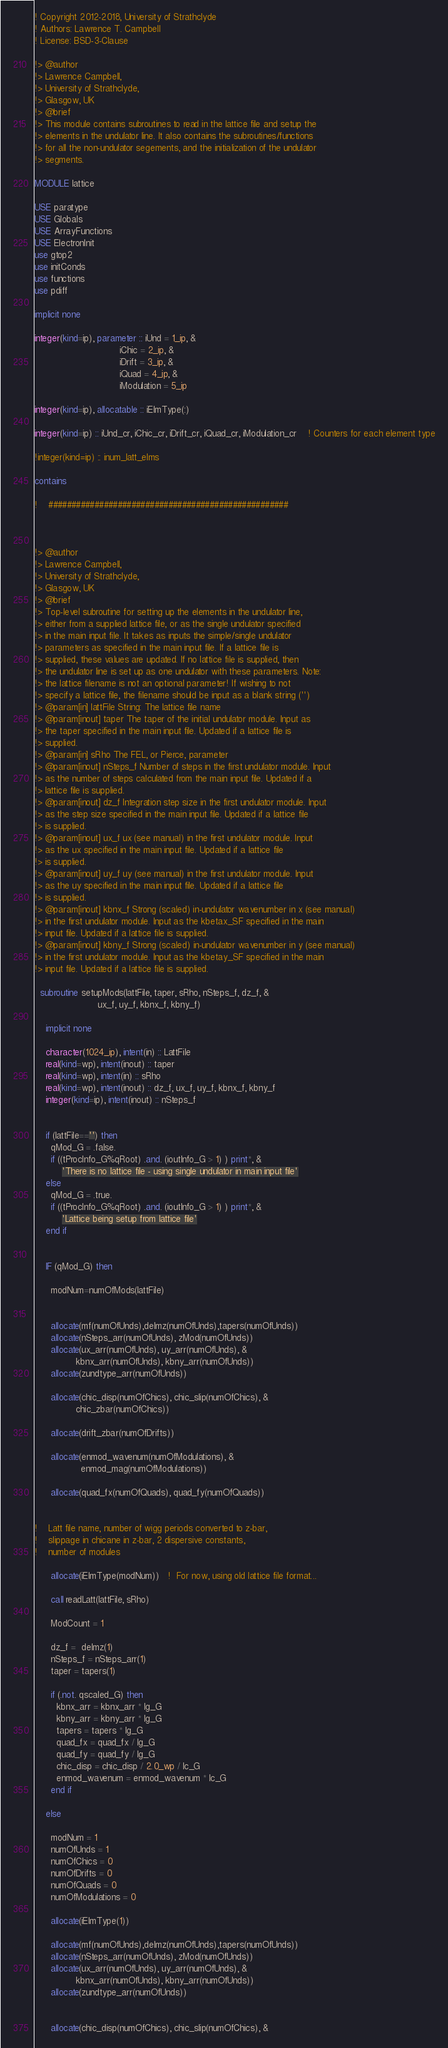<code> <loc_0><loc_0><loc_500><loc_500><_FORTRAN_>! Copyright 2012-2018, University of Strathclyde
! Authors: Lawrence T. Campbell
! License: BSD-3-Clause

!> @author
!> Lawrence Campbell,
!> University of Strathclyde, 
!> Glasgow, UK
!> @brief
!> This module contains subroutines to read in the lattice file and setup the
!> elements in the undulator line. It also contains the subroutines/functions 
!> for all the non-undulator segements, and the initialization of the undulator
!> segments.

MODULE lattice

USE paratype
USE Globals
USE ArrayFunctions
USE ElectronInit
use gtop2
use initConds
use functions
use pdiff

implicit none

integer(kind=ip), parameter :: iUnd = 1_ip, &
                               iChic = 2_ip, &
                               iDrift = 3_ip, &
                               iQuad = 4_ip, &
                               iModulation = 5_ip

integer(kind=ip), allocatable :: iElmType(:)

integer(kind=ip) :: iUnd_cr, iChic_cr, iDrift_cr, iQuad_cr, iModulation_cr    ! Counters for each element type

!integer(kind=ip) :: inum_latt_elms

contains

!    ####################################################



!> @author
!> Lawrence Campbell,
!> University of Strathclyde, 
!> Glasgow, UK
!> @brief
!> Top-level subroutine for setting up the elements in the undulator line, 
!> either from a supplied lattice file, or as the single undulator specified
!> in the main input file. It takes as inputs the simple/single undulator 
!> parameters as specified in the main input file. If a lattice file is 
!> supplied, these values are updated. If no lattice file is supplied, then
!> the undulator line is set up as one undulator with these parameters. Note:
!> the lattice filename is not an optional parameter! If wishing to not 
!> specify a lattice file, the filename should be input as a blank string ('')
!> @param[in] lattFile String: The lattice file name
!> @param[inout] taper The taper of the initial undulator module. Input as 
!> the taper specified in the main input file. Updated if a lattice file is 
!> supplied.
!> @param[in] sRho The FEL, or Pierce, parameter
!> @param[inout] nSteps_f Number of steps in the first undulator module. Input
!> as the number of steps calculated from the main input file. Updated if a  
!> lattice file is supplied.
!> @param[inout] dz_f Integration step size in the first undulator module. Input
!> as the step size specified in the main input file. Updated if a lattice file 
!> is supplied.
!> @param[inout] ux_f ux (see manual) in the first undulator module. Input
!> as the ux specified in the main input file. Updated if a lattice file 
!> is supplied.
!> @param[inout] uy_f uy (see manual) in the first undulator module. Input
!> as the uy specified in the main input file. Updated if a lattice file 
!> is supplied.
!> @param[inout] kbnx_f Strong (scaled) in-undulator wavenumber in x (see manual) 
!> in the first undulator module. Input as the kbetax_SF specified in the main 
!> input file. Updated if a lattice file is supplied.
!> @param[inout] kbny_f Strong (scaled) in-undulator wavenumber in y (see manual) 
!> in the first undulator module. Input as the kbetay_SF specified in the main 
!> input file. Updated if a lattice file is supplied.

  subroutine setupMods(lattFile, taper, sRho, nSteps_f, dz_f, &
                       ux_f, uy_f, kbnx_f, kbny_f)

    implicit none

    character(1024_ip), intent(in) :: LattFile 
    real(kind=wp), intent(inout) :: taper
    real(kind=wp), intent(in) :: sRho
    real(kind=wp), intent(inout) :: dz_f, ux_f, uy_f, kbnx_f, kbny_f
    integer(kind=ip), intent(inout) :: nSteps_f


    if (lattFile=='') then
      qMod_G = .false.
      if ((tProcInfo_G%qRoot) .and. (ioutInfo_G > 1) ) print*, &
          'There is no lattice file - using single undulator in main input file'
    else
      qMod_G = .true.
      if ((tProcInfo_G%qRoot) .and. (ioutInfo_G > 1) ) print*, &
          'Lattice being setup from lattice file'
    end if


    IF (qMod_G) then

      modNum=numOfMods(lattFile)


      allocate(mf(numOfUnds),delmz(numOfUnds),tapers(numOfUnds))
      allocate(nSteps_arr(numOfUnds), zMod(numOfUnds))
      allocate(ux_arr(numOfUnds), uy_arr(numOfUnds), &
               kbnx_arr(numOfUnds), kbny_arr(numOfUnds))
      allocate(zundtype_arr(numOfUnds))

      allocate(chic_disp(numOfChics), chic_slip(numOfChics), &
               chic_zbar(numOfChics))

      allocate(drift_zbar(numOfDrifts))

      allocate(enmod_wavenum(numOfModulations), &
                 enmod_mag(numOfModulations)) 

      allocate(quad_fx(numOfQuads), quad_fy(numOfQuads))


!    Latt file name, number of wigg periods converted to z-bar,
!    slippage in chicane in z-bar, 2 dispersive constants,
!    number of modules

      allocate(iElmType(modNum))   !  For now, using old lattice file format...

      call readLatt(lattFile, sRho)

      ModCount = 1

      dz_f =  delmz(1)
      nSteps_f = nSteps_arr(1)
      taper = tapers(1)

      if (.not. qscaled_G) then
        kbnx_arr = kbnx_arr * lg_G
        kbny_arr = kbny_arr * lg_G
        tapers = tapers * lg_G
        quad_fx = quad_fx / lg_G
        quad_fy = quad_fy / lg_G
        chic_disp = chic_disp / 2.0_wp / lc_G
        enmod_wavenum = enmod_wavenum * lc_G
      end if

    else

      modNum = 1
      numOfUnds = 1
      numOfChics = 0
      numOfDrifts = 0
      numOfQuads = 0
      numOfModulations = 0

      allocate(iElmType(1))

      allocate(mf(numOfUnds),delmz(numOfUnds),tapers(numOfUnds))
      allocate(nSteps_arr(numOfUnds), zMod(numOfUnds))
      allocate(ux_arr(numOfUnds), uy_arr(numOfUnds), &
               kbnx_arr(numOfUnds), kbny_arr(numOfUnds))
      allocate(zundtype_arr(numOfUnds))


      allocate(chic_disp(numOfChics), chic_slip(numOfChics), &</code> 